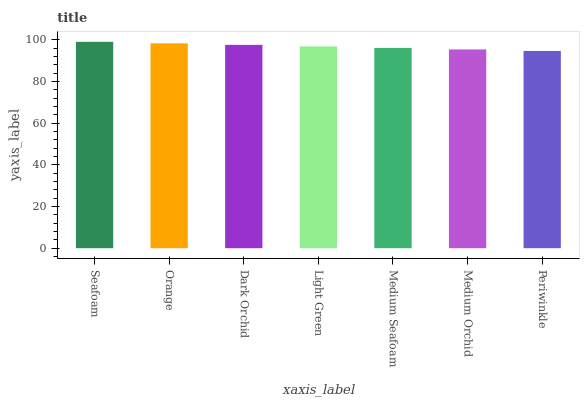Is Orange the minimum?
Answer yes or no. No. Is Orange the maximum?
Answer yes or no. No. Is Seafoam greater than Orange?
Answer yes or no. Yes. Is Orange less than Seafoam?
Answer yes or no. Yes. Is Orange greater than Seafoam?
Answer yes or no. No. Is Seafoam less than Orange?
Answer yes or no. No. Is Light Green the high median?
Answer yes or no. Yes. Is Light Green the low median?
Answer yes or no. Yes. Is Medium Orchid the high median?
Answer yes or no. No. Is Periwinkle the low median?
Answer yes or no. No. 